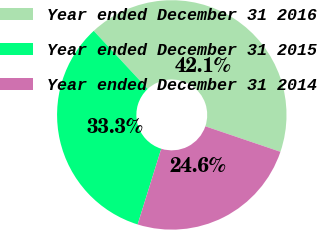Convert chart to OTSL. <chart><loc_0><loc_0><loc_500><loc_500><pie_chart><fcel>Year ended December 31 2016<fcel>Year ended December 31 2015<fcel>Year ended December 31 2014<nl><fcel>42.12%<fcel>33.28%<fcel>24.6%<nl></chart> 